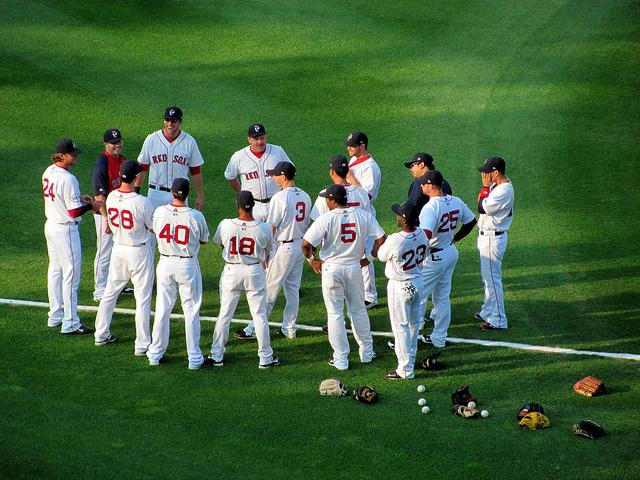Which equipment would be fastest for them to use?

Choices:
A) mitts
B) shoes
C) baseball bats
D) balls shoes 